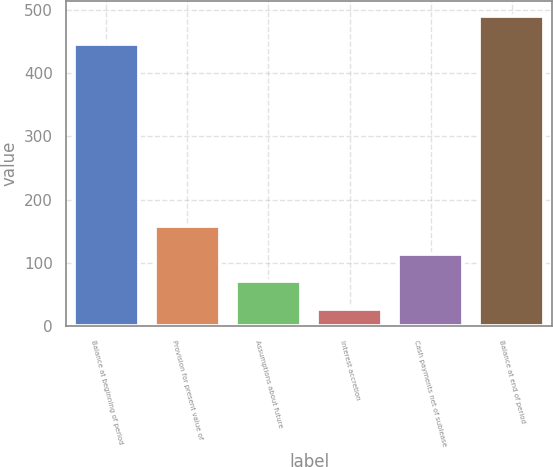<chart> <loc_0><loc_0><loc_500><loc_500><bar_chart><fcel>Balance at beginning of period<fcel>Provision for present value of<fcel>Assumptions about future<fcel>Interest accretion<fcel>Cash payments net of sublease<fcel>Balance at end of period<nl><fcel>446<fcel>158.7<fcel>70.9<fcel>27<fcel>114.8<fcel>489.9<nl></chart> 